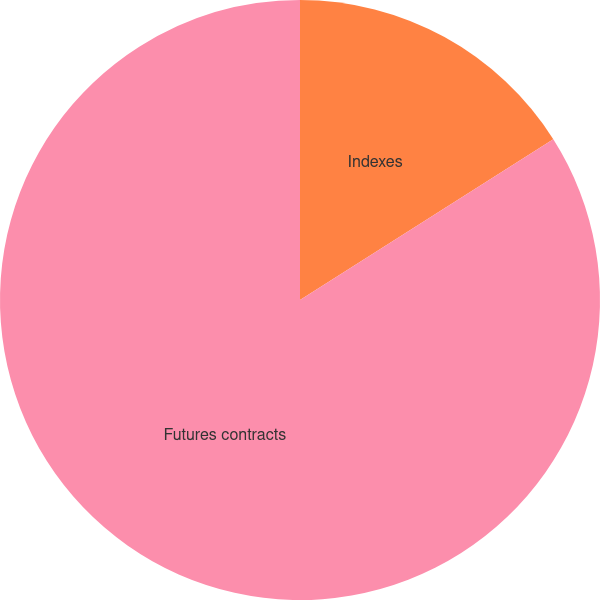Convert chart to OTSL. <chart><loc_0><loc_0><loc_500><loc_500><pie_chart><fcel>Indexes<fcel>Futures contracts<nl><fcel>16.0%<fcel>84.0%<nl></chart> 